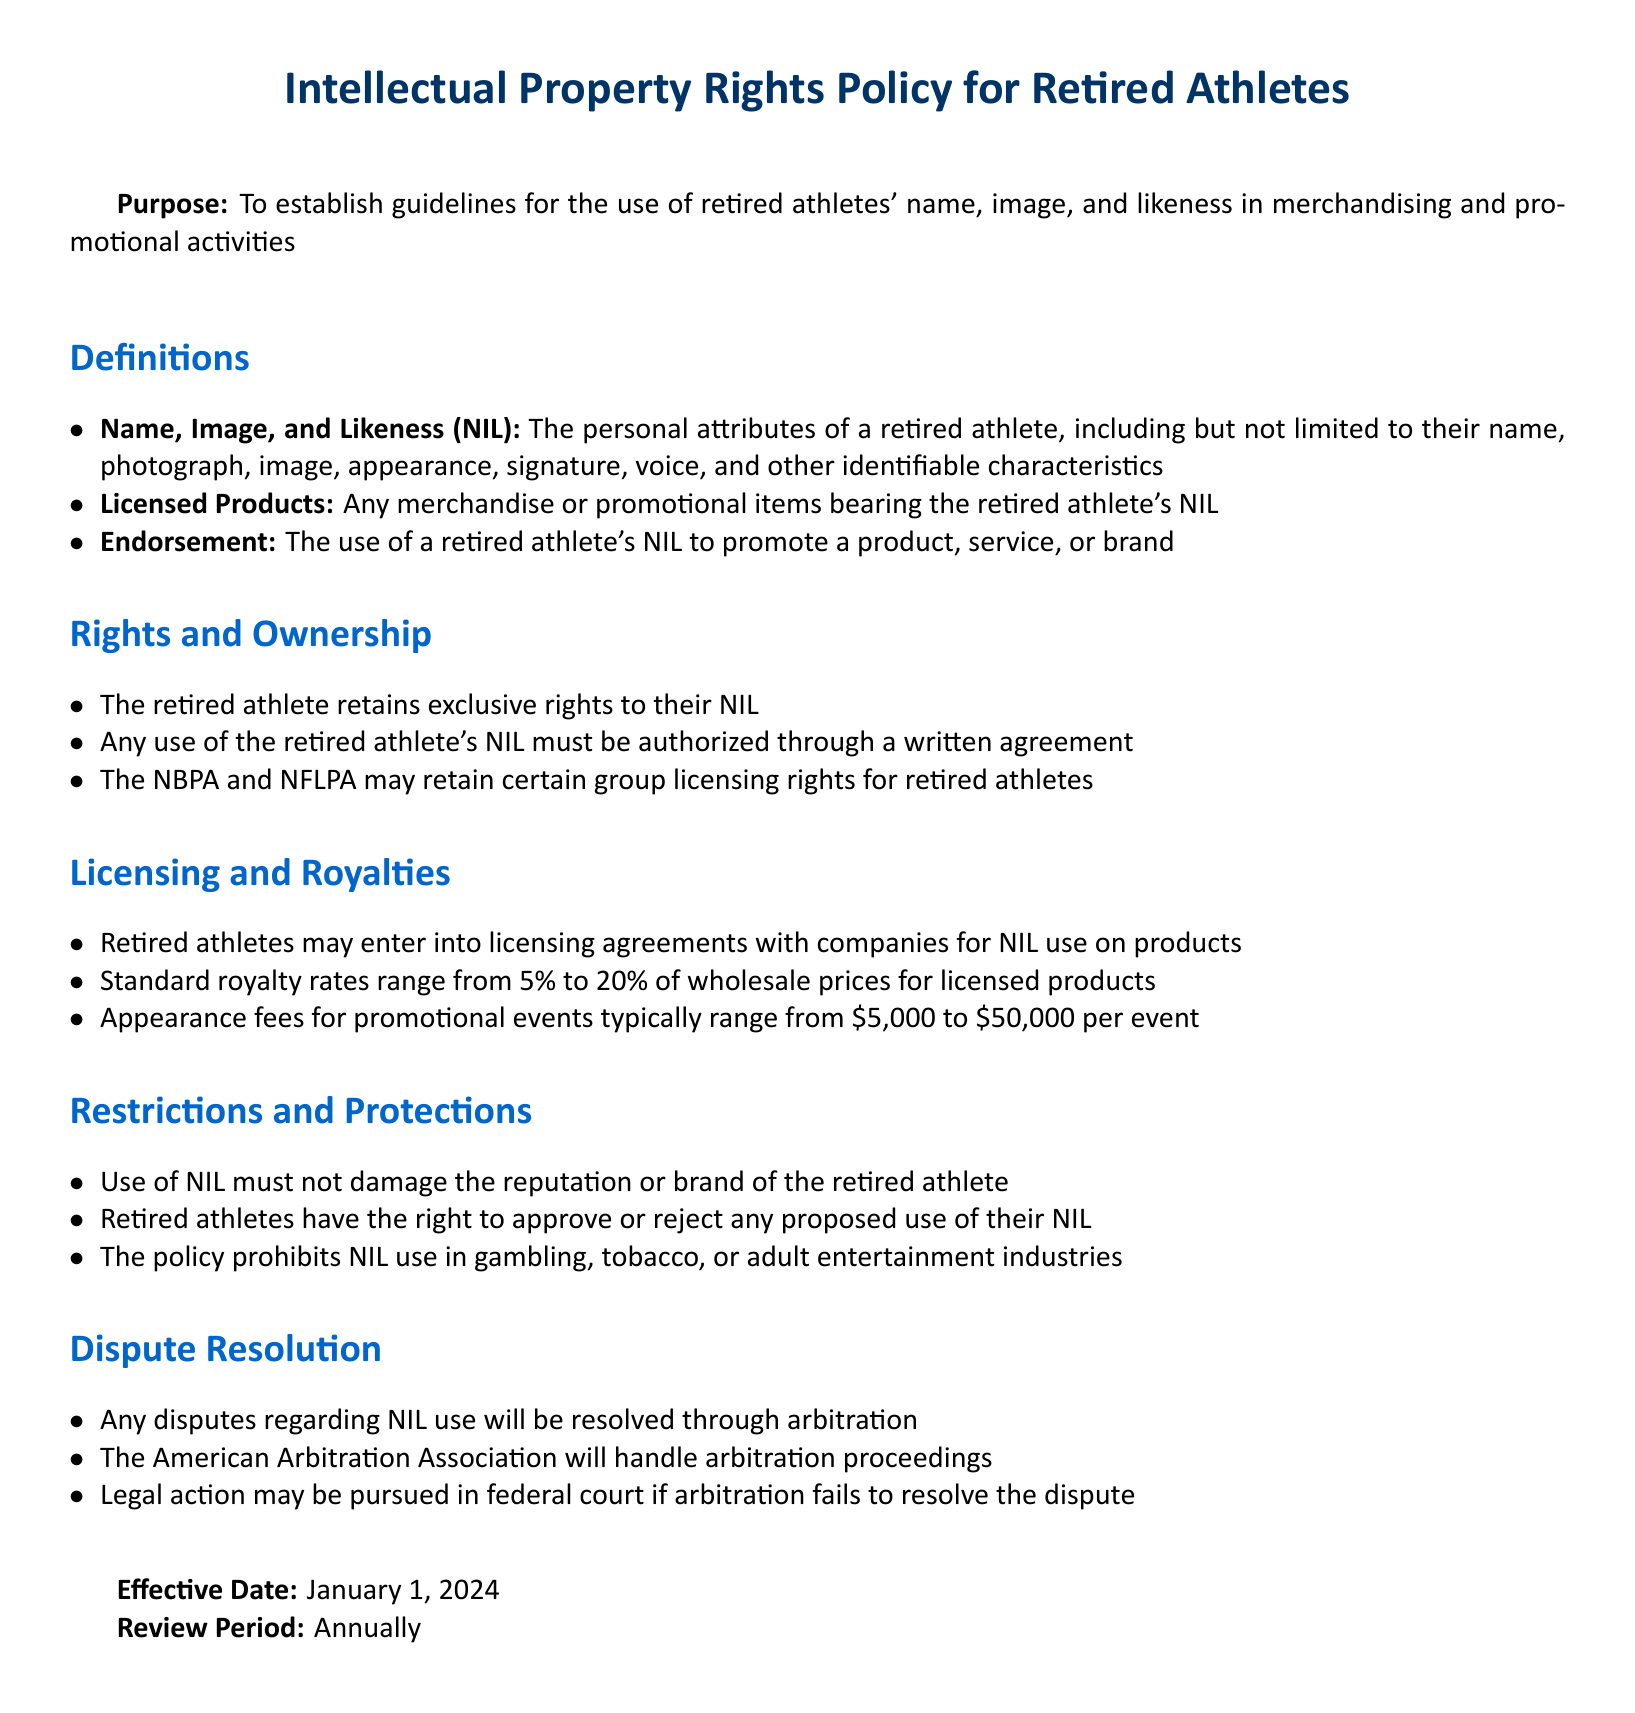What is the effective date of the policy? The effective date is stated at the end of the document.
Answer: January 1, 2024 What is the range of standard royalty rates for licensed products? The document specifies that royalty rates range for licensed products.
Answer: 5% to 20% Who handles arbitration proceedings for disputes? The document mentions which organization is responsible for arbitration proceedings.
Answer: American Arbitration Association What is the upper limit for appearance fees per event? The document provides information about appearance fees and their range.
Answer: $50,000 What is required for any use of a retired athlete's NIL? The text specifies what must be obtained for using a retired athlete's NIL.
Answer: Written agreement What industries are prohibited for NIL use? The policy outlines specific industries where NIL use is not allowed.
Answer: Gambling, tobacco, adult entertainment What must not be damaged by the use of NIL? The policy emphasizes a certain aspect that must be protected regarding NIL use.
Answer: Reputation or brand What are the defined personal attributes of a retired athlete under NIL? The definitions section lists various attributes that fall under NIL.
Answer: Name, photograph, image, appearance, signature, voice, identifiable characteristics What rights do retired athletes retain regarding their NIL? The document lists the rights retained by retired athletes.
Answer: Exclusive rights 